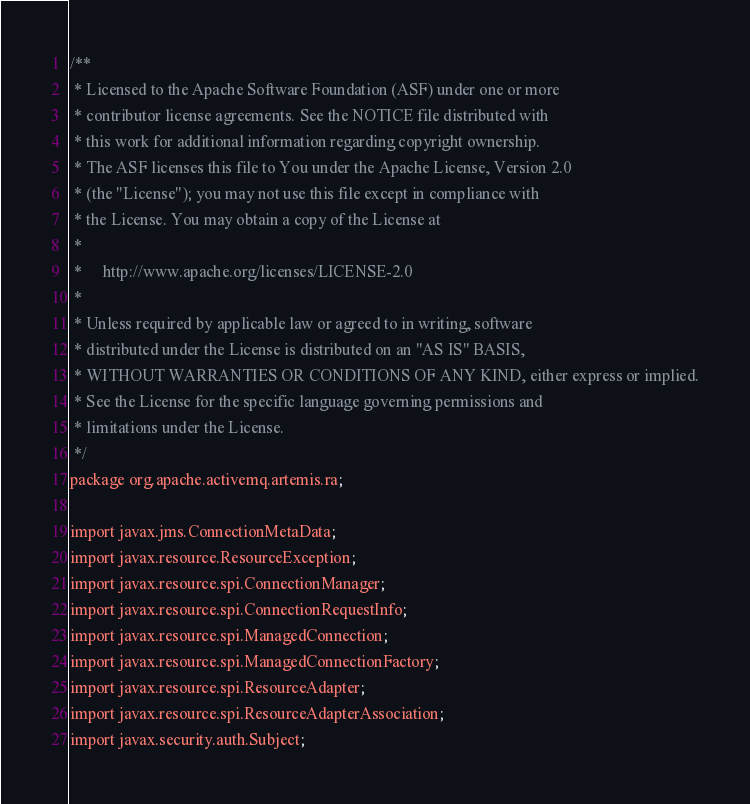<code> <loc_0><loc_0><loc_500><loc_500><_Java_>/**
 * Licensed to the Apache Software Foundation (ASF) under one or more
 * contributor license agreements. See the NOTICE file distributed with
 * this work for additional information regarding copyright ownership.
 * The ASF licenses this file to You under the Apache License, Version 2.0
 * (the "License"); you may not use this file except in compliance with
 * the License. You may obtain a copy of the License at
 *
 *     http://www.apache.org/licenses/LICENSE-2.0
 *
 * Unless required by applicable law or agreed to in writing, software
 * distributed under the License is distributed on an "AS IS" BASIS,
 * WITHOUT WARRANTIES OR CONDITIONS OF ANY KIND, either express or implied.
 * See the License for the specific language governing permissions and
 * limitations under the License.
 */
package org.apache.activemq.artemis.ra;

import javax.jms.ConnectionMetaData;
import javax.resource.ResourceException;
import javax.resource.spi.ConnectionManager;
import javax.resource.spi.ConnectionRequestInfo;
import javax.resource.spi.ManagedConnection;
import javax.resource.spi.ManagedConnectionFactory;
import javax.resource.spi.ResourceAdapter;
import javax.resource.spi.ResourceAdapterAssociation;
import javax.security.auth.Subject;</code> 